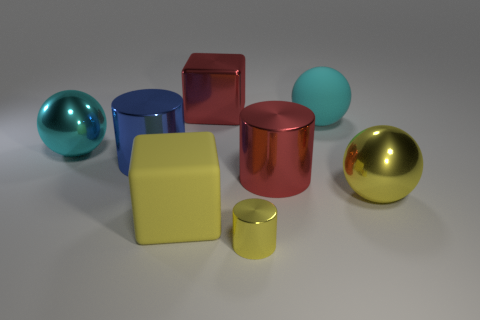Add 2 big purple matte cubes. How many objects exist? 10 Subtract all spheres. How many objects are left? 5 Add 1 red shiny cubes. How many red shiny cubes exist? 2 Subtract 0 gray cubes. How many objects are left? 8 Subtract all things. Subtract all blue blocks. How many objects are left? 0 Add 2 large metal balls. How many large metal balls are left? 4 